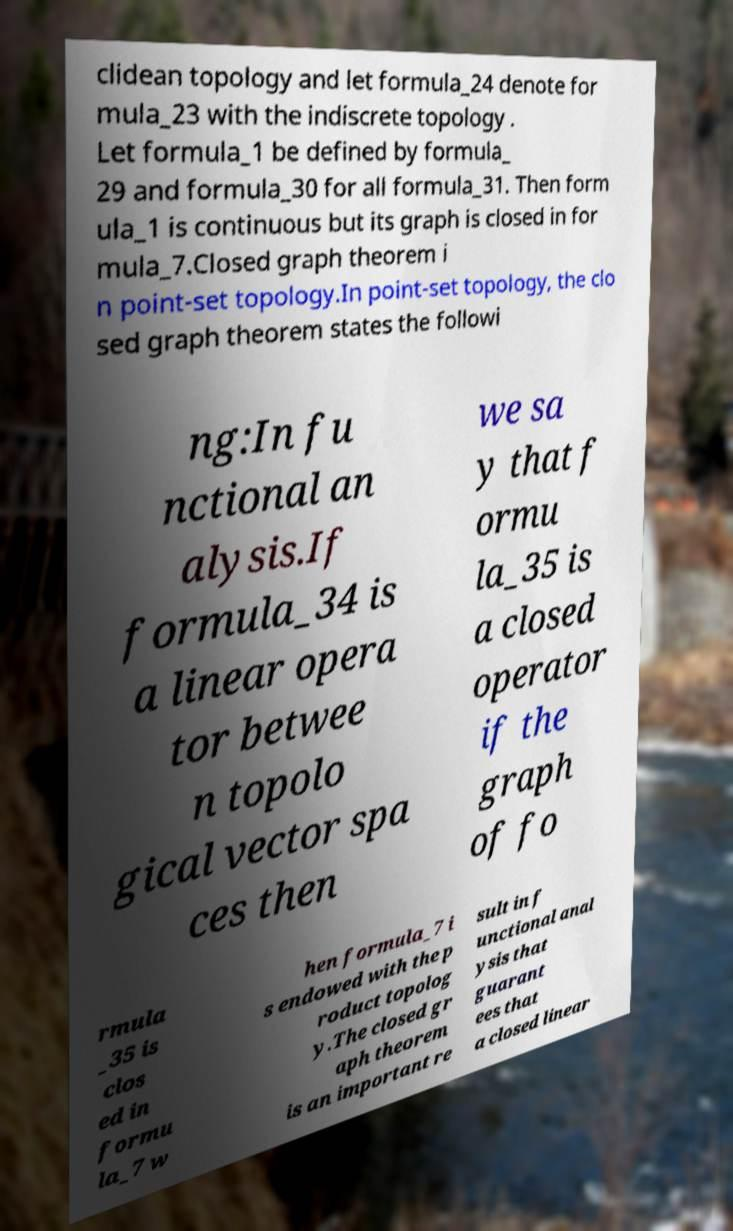For documentation purposes, I need the text within this image transcribed. Could you provide that? clidean topology and let formula_24 denote for mula_23 with the indiscrete topology . Let formula_1 be defined by formula_ 29 and formula_30 for all formula_31. Then form ula_1 is continuous but its graph is closed in for mula_7.Closed graph theorem i n point-set topology.In point-set topology, the clo sed graph theorem states the followi ng:In fu nctional an alysis.If formula_34 is a linear opera tor betwee n topolo gical vector spa ces then we sa y that f ormu la_35 is a closed operator if the graph of fo rmula _35 is clos ed in formu la_7 w hen formula_7 i s endowed with the p roduct topolog y.The closed gr aph theorem is an important re sult in f unctional anal ysis that guarant ees that a closed linear 